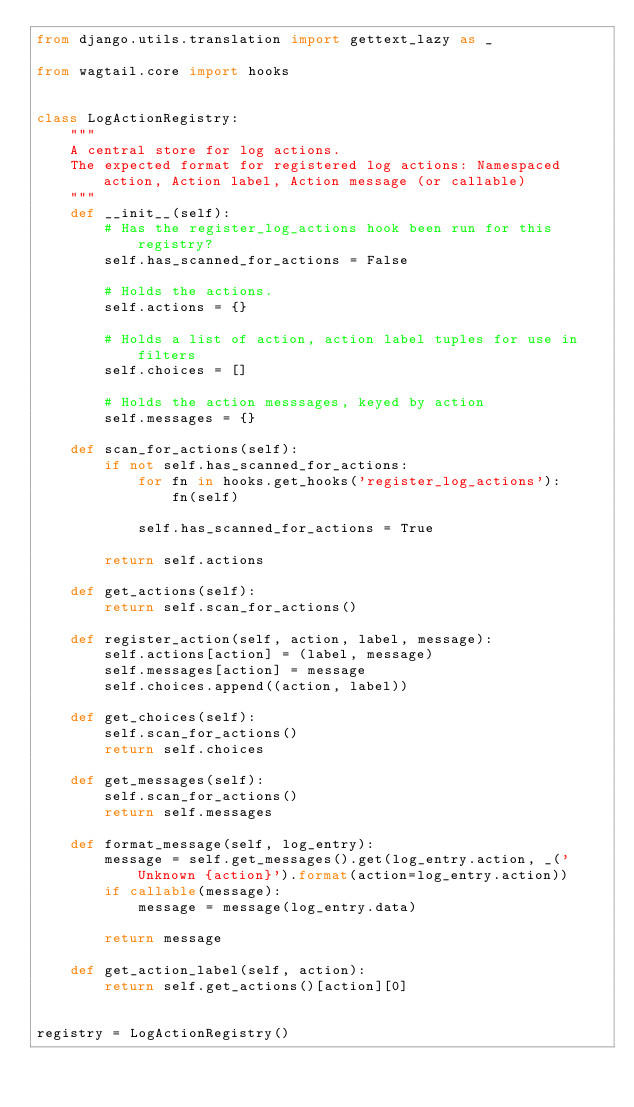<code> <loc_0><loc_0><loc_500><loc_500><_Python_>from django.utils.translation import gettext_lazy as _

from wagtail.core import hooks


class LogActionRegistry:
    """
    A central store for log actions.
    The expected format for registered log actions: Namespaced action, Action label, Action message (or callable)
    """
    def __init__(self):
        # Has the register_log_actions hook been run for this registry?
        self.has_scanned_for_actions = False

        # Holds the actions.
        self.actions = {}

        # Holds a list of action, action label tuples for use in filters
        self.choices = []

        # Holds the action messsages, keyed by action
        self.messages = {}

    def scan_for_actions(self):
        if not self.has_scanned_for_actions:
            for fn in hooks.get_hooks('register_log_actions'):
                fn(self)

            self.has_scanned_for_actions = True

        return self.actions

    def get_actions(self):
        return self.scan_for_actions()

    def register_action(self, action, label, message):
        self.actions[action] = (label, message)
        self.messages[action] = message
        self.choices.append((action, label))

    def get_choices(self):
        self.scan_for_actions()
        return self.choices

    def get_messages(self):
        self.scan_for_actions()
        return self.messages

    def format_message(self, log_entry):
        message = self.get_messages().get(log_entry.action, _('Unknown {action}').format(action=log_entry.action))
        if callable(message):
            message = message(log_entry.data)

        return message

    def get_action_label(self, action):
        return self.get_actions()[action][0]


registry = LogActionRegistry()
</code> 